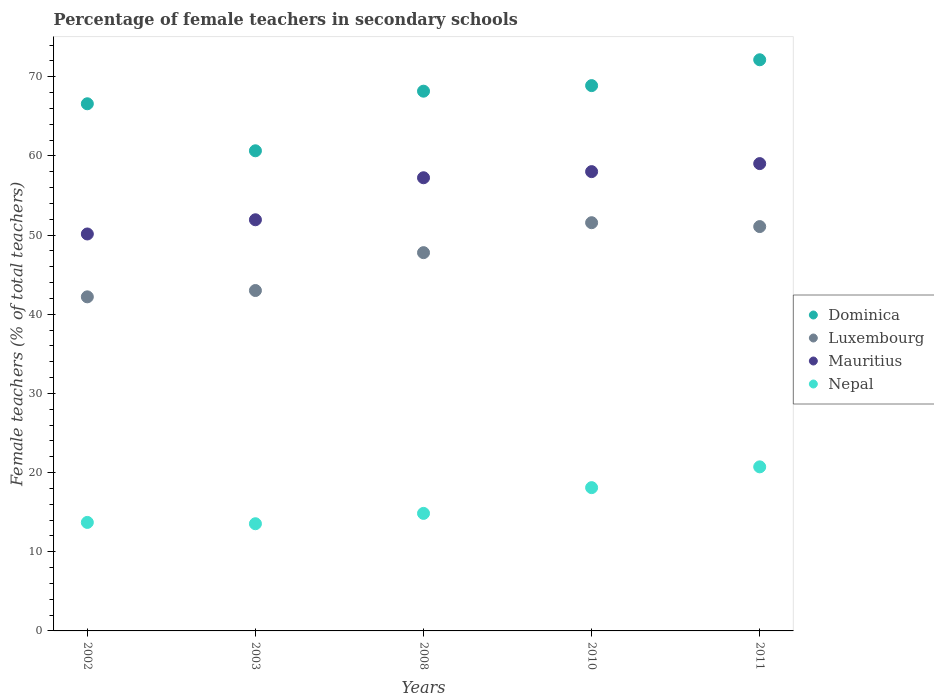How many different coloured dotlines are there?
Provide a short and direct response. 4. Is the number of dotlines equal to the number of legend labels?
Offer a terse response. Yes. What is the percentage of female teachers in Nepal in 2003?
Your answer should be very brief. 13.54. Across all years, what is the maximum percentage of female teachers in Dominica?
Your response must be concise. 72.15. Across all years, what is the minimum percentage of female teachers in Nepal?
Your answer should be very brief. 13.54. In which year was the percentage of female teachers in Luxembourg minimum?
Offer a terse response. 2002. What is the total percentage of female teachers in Luxembourg in the graph?
Offer a very short reply. 235.63. What is the difference between the percentage of female teachers in Nepal in 2003 and that in 2008?
Give a very brief answer. -1.31. What is the difference between the percentage of female teachers in Nepal in 2002 and the percentage of female teachers in Dominica in 2008?
Offer a very short reply. -54.48. What is the average percentage of female teachers in Mauritius per year?
Ensure brevity in your answer.  55.28. In the year 2010, what is the difference between the percentage of female teachers in Mauritius and percentage of female teachers in Dominica?
Provide a short and direct response. -10.86. In how many years, is the percentage of female teachers in Mauritius greater than 70 %?
Provide a succinct answer. 0. What is the ratio of the percentage of female teachers in Dominica in 2003 to that in 2011?
Give a very brief answer. 0.84. Is the percentage of female teachers in Nepal in 2002 less than that in 2010?
Offer a terse response. Yes. Is the difference between the percentage of female teachers in Mauritius in 2002 and 2010 greater than the difference between the percentage of female teachers in Dominica in 2002 and 2010?
Provide a succinct answer. No. What is the difference between the highest and the second highest percentage of female teachers in Mauritius?
Ensure brevity in your answer.  1.01. What is the difference between the highest and the lowest percentage of female teachers in Nepal?
Ensure brevity in your answer.  7.19. Is the sum of the percentage of female teachers in Dominica in 2003 and 2010 greater than the maximum percentage of female teachers in Nepal across all years?
Provide a short and direct response. Yes. Is the percentage of female teachers in Dominica strictly less than the percentage of female teachers in Mauritius over the years?
Provide a short and direct response. No. How many years are there in the graph?
Give a very brief answer. 5. Are the values on the major ticks of Y-axis written in scientific E-notation?
Make the answer very short. No. Does the graph contain any zero values?
Keep it short and to the point. No. How many legend labels are there?
Provide a short and direct response. 4. How are the legend labels stacked?
Provide a succinct answer. Vertical. What is the title of the graph?
Provide a succinct answer. Percentage of female teachers in secondary schools. Does "Small states" appear as one of the legend labels in the graph?
Provide a short and direct response. No. What is the label or title of the X-axis?
Make the answer very short. Years. What is the label or title of the Y-axis?
Offer a very short reply. Female teachers (% of total teachers). What is the Female teachers (% of total teachers) in Dominica in 2002?
Ensure brevity in your answer.  66.59. What is the Female teachers (% of total teachers) in Luxembourg in 2002?
Your answer should be very brief. 42.2. What is the Female teachers (% of total teachers) of Mauritius in 2002?
Ensure brevity in your answer.  50.14. What is the Female teachers (% of total teachers) in Nepal in 2002?
Your answer should be compact. 13.71. What is the Female teachers (% of total teachers) of Dominica in 2003?
Ensure brevity in your answer.  60.65. What is the Female teachers (% of total teachers) in Luxembourg in 2003?
Ensure brevity in your answer.  43. What is the Female teachers (% of total teachers) of Mauritius in 2003?
Your answer should be compact. 51.94. What is the Female teachers (% of total teachers) of Nepal in 2003?
Offer a terse response. 13.54. What is the Female teachers (% of total teachers) in Dominica in 2008?
Offer a very short reply. 68.18. What is the Female teachers (% of total teachers) of Luxembourg in 2008?
Your answer should be very brief. 47.78. What is the Female teachers (% of total teachers) of Mauritius in 2008?
Provide a short and direct response. 57.25. What is the Female teachers (% of total teachers) of Nepal in 2008?
Make the answer very short. 14.85. What is the Female teachers (% of total teachers) in Dominica in 2010?
Your answer should be compact. 68.88. What is the Female teachers (% of total teachers) of Luxembourg in 2010?
Make the answer very short. 51.57. What is the Female teachers (% of total teachers) of Mauritius in 2010?
Give a very brief answer. 58.02. What is the Female teachers (% of total teachers) of Nepal in 2010?
Make the answer very short. 18.1. What is the Female teachers (% of total teachers) in Dominica in 2011?
Keep it short and to the point. 72.15. What is the Female teachers (% of total teachers) of Luxembourg in 2011?
Your response must be concise. 51.08. What is the Female teachers (% of total teachers) of Mauritius in 2011?
Keep it short and to the point. 59.03. What is the Female teachers (% of total teachers) in Nepal in 2011?
Make the answer very short. 20.73. Across all years, what is the maximum Female teachers (% of total teachers) in Dominica?
Provide a short and direct response. 72.15. Across all years, what is the maximum Female teachers (% of total teachers) in Luxembourg?
Your response must be concise. 51.57. Across all years, what is the maximum Female teachers (% of total teachers) in Mauritius?
Make the answer very short. 59.03. Across all years, what is the maximum Female teachers (% of total teachers) in Nepal?
Offer a very short reply. 20.73. Across all years, what is the minimum Female teachers (% of total teachers) of Dominica?
Your answer should be very brief. 60.65. Across all years, what is the minimum Female teachers (% of total teachers) of Luxembourg?
Give a very brief answer. 42.2. Across all years, what is the minimum Female teachers (% of total teachers) of Mauritius?
Provide a succinct answer. 50.14. Across all years, what is the minimum Female teachers (% of total teachers) of Nepal?
Your response must be concise. 13.54. What is the total Female teachers (% of total teachers) of Dominica in the graph?
Keep it short and to the point. 336.46. What is the total Female teachers (% of total teachers) in Luxembourg in the graph?
Your answer should be compact. 235.63. What is the total Female teachers (% of total teachers) in Mauritius in the graph?
Ensure brevity in your answer.  276.38. What is the total Female teachers (% of total teachers) in Nepal in the graph?
Your answer should be compact. 80.92. What is the difference between the Female teachers (% of total teachers) of Dominica in 2002 and that in 2003?
Your answer should be compact. 5.94. What is the difference between the Female teachers (% of total teachers) of Luxembourg in 2002 and that in 2003?
Ensure brevity in your answer.  -0.8. What is the difference between the Female teachers (% of total teachers) of Mauritius in 2002 and that in 2003?
Give a very brief answer. -1.8. What is the difference between the Female teachers (% of total teachers) in Nepal in 2002 and that in 2003?
Give a very brief answer. 0.17. What is the difference between the Female teachers (% of total teachers) of Dominica in 2002 and that in 2008?
Make the answer very short. -1.59. What is the difference between the Female teachers (% of total teachers) in Luxembourg in 2002 and that in 2008?
Ensure brevity in your answer.  -5.58. What is the difference between the Female teachers (% of total teachers) in Mauritius in 2002 and that in 2008?
Make the answer very short. -7.1. What is the difference between the Female teachers (% of total teachers) of Nepal in 2002 and that in 2008?
Offer a terse response. -1.14. What is the difference between the Female teachers (% of total teachers) in Dominica in 2002 and that in 2010?
Make the answer very short. -2.29. What is the difference between the Female teachers (% of total teachers) in Luxembourg in 2002 and that in 2010?
Provide a succinct answer. -9.37. What is the difference between the Female teachers (% of total teachers) of Mauritius in 2002 and that in 2010?
Offer a terse response. -7.88. What is the difference between the Female teachers (% of total teachers) of Nepal in 2002 and that in 2010?
Ensure brevity in your answer.  -4.39. What is the difference between the Female teachers (% of total teachers) of Dominica in 2002 and that in 2011?
Provide a short and direct response. -5.56. What is the difference between the Female teachers (% of total teachers) of Luxembourg in 2002 and that in 2011?
Offer a terse response. -8.88. What is the difference between the Female teachers (% of total teachers) of Mauritius in 2002 and that in 2011?
Provide a succinct answer. -8.89. What is the difference between the Female teachers (% of total teachers) in Nepal in 2002 and that in 2011?
Provide a succinct answer. -7.02. What is the difference between the Female teachers (% of total teachers) in Dominica in 2003 and that in 2008?
Make the answer very short. -7.53. What is the difference between the Female teachers (% of total teachers) of Luxembourg in 2003 and that in 2008?
Make the answer very short. -4.78. What is the difference between the Female teachers (% of total teachers) in Mauritius in 2003 and that in 2008?
Offer a very short reply. -5.31. What is the difference between the Female teachers (% of total teachers) in Nepal in 2003 and that in 2008?
Give a very brief answer. -1.31. What is the difference between the Female teachers (% of total teachers) in Dominica in 2003 and that in 2010?
Offer a terse response. -8.23. What is the difference between the Female teachers (% of total teachers) of Luxembourg in 2003 and that in 2010?
Your answer should be very brief. -8.57. What is the difference between the Female teachers (% of total teachers) in Mauritius in 2003 and that in 2010?
Offer a terse response. -6.08. What is the difference between the Female teachers (% of total teachers) in Nepal in 2003 and that in 2010?
Make the answer very short. -4.56. What is the difference between the Female teachers (% of total teachers) of Dominica in 2003 and that in 2011?
Make the answer very short. -11.5. What is the difference between the Female teachers (% of total teachers) of Luxembourg in 2003 and that in 2011?
Keep it short and to the point. -8.08. What is the difference between the Female teachers (% of total teachers) of Mauritius in 2003 and that in 2011?
Your answer should be compact. -7.1. What is the difference between the Female teachers (% of total teachers) of Nepal in 2003 and that in 2011?
Keep it short and to the point. -7.19. What is the difference between the Female teachers (% of total teachers) in Dominica in 2008 and that in 2010?
Ensure brevity in your answer.  -0.7. What is the difference between the Female teachers (% of total teachers) in Luxembourg in 2008 and that in 2010?
Your response must be concise. -3.78. What is the difference between the Female teachers (% of total teachers) in Mauritius in 2008 and that in 2010?
Provide a succinct answer. -0.77. What is the difference between the Female teachers (% of total teachers) in Nepal in 2008 and that in 2010?
Provide a succinct answer. -3.25. What is the difference between the Female teachers (% of total teachers) in Dominica in 2008 and that in 2011?
Keep it short and to the point. -3.97. What is the difference between the Female teachers (% of total teachers) of Luxembourg in 2008 and that in 2011?
Give a very brief answer. -3.29. What is the difference between the Female teachers (% of total teachers) of Mauritius in 2008 and that in 2011?
Your answer should be very brief. -1.79. What is the difference between the Female teachers (% of total teachers) of Nepal in 2008 and that in 2011?
Provide a short and direct response. -5.88. What is the difference between the Female teachers (% of total teachers) of Dominica in 2010 and that in 2011?
Your answer should be compact. -3.27. What is the difference between the Female teachers (% of total teachers) in Luxembourg in 2010 and that in 2011?
Your answer should be compact. 0.49. What is the difference between the Female teachers (% of total teachers) of Mauritius in 2010 and that in 2011?
Give a very brief answer. -1.01. What is the difference between the Female teachers (% of total teachers) of Nepal in 2010 and that in 2011?
Your response must be concise. -2.63. What is the difference between the Female teachers (% of total teachers) of Dominica in 2002 and the Female teachers (% of total teachers) of Luxembourg in 2003?
Keep it short and to the point. 23.59. What is the difference between the Female teachers (% of total teachers) in Dominica in 2002 and the Female teachers (% of total teachers) in Mauritius in 2003?
Make the answer very short. 14.65. What is the difference between the Female teachers (% of total teachers) of Dominica in 2002 and the Female teachers (% of total teachers) of Nepal in 2003?
Your response must be concise. 53.05. What is the difference between the Female teachers (% of total teachers) in Luxembourg in 2002 and the Female teachers (% of total teachers) in Mauritius in 2003?
Ensure brevity in your answer.  -9.74. What is the difference between the Female teachers (% of total teachers) in Luxembourg in 2002 and the Female teachers (% of total teachers) in Nepal in 2003?
Your answer should be very brief. 28.66. What is the difference between the Female teachers (% of total teachers) of Mauritius in 2002 and the Female teachers (% of total teachers) of Nepal in 2003?
Offer a very short reply. 36.6. What is the difference between the Female teachers (% of total teachers) of Dominica in 2002 and the Female teachers (% of total teachers) of Luxembourg in 2008?
Give a very brief answer. 18.81. What is the difference between the Female teachers (% of total teachers) of Dominica in 2002 and the Female teachers (% of total teachers) of Mauritius in 2008?
Offer a very short reply. 9.35. What is the difference between the Female teachers (% of total teachers) in Dominica in 2002 and the Female teachers (% of total teachers) in Nepal in 2008?
Keep it short and to the point. 51.74. What is the difference between the Female teachers (% of total teachers) in Luxembourg in 2002 and the Female teachers (% of total teachers) in Mauritius in 2008?
Provide a succinct answer. -15.04. What is the difference between the Female teachers (% of total teachers) in Luxembourg in 2002 and the Female teachers (% of total teachers) in Nepal in 2008?
Keep it short and to the point. 27.36. What is the difference between the Female teachers (% of total teachers) in Mauritius in 2002 and the Female teachers (% of total teachers) in Nepal in 2008?
Keep it short and to the point. 35.3. What is the difference between the Female teachers (% of total teachers) in Dominica in 2002 and the Female teachers (% of total teachers) in Luxembourg in 2010?
Your answer should be very brief. 15.02. What is the difference between the Female teachers (% of total teachers) of Dominica in 2002 and the Female teachers (% of total teachers) of Mauritius in 2010?
Make the answer very short. 8.57. What is the difference between the Female teachers (% of total teachers) of Dominica in 2002 and the Female teachers (% of total teachers) of Nepal in 2010?
Ensure brevity in your answer.  48.49. What is the difference between the Female teachers (% of total teachers) of Luxembourg in 2002 and the Female teachers (% of total teachers) of Mauritius in 2010?
Provide a short and direct response. -15.82. What is the difference between the Female teachers (% of total teachers) in Luxembourg in 2002 and the Female teachers (% of total teachers) in Nepal in 2010?
Keep it short and to the point. 24.1. What is the difference between the Female teachers (% of total teachers) in Mauritius in 2002 and the Female teachers (% of total teachers) in Nepal in 2010?
Your answer should be compact. 32.04. What is the difference between the Female teachers (% of total teachers) of Dominica in 2002 and the Female teachers (% of total teachers) of Luxembourg in 2011?
Keep it short and to the point. 15.51. What is the difference between the Female teachers (% of total teachers) of Dominica in 2002 and the Female teachers (% of total teachers) of Mauritius in 2011?
Ensure brevity in your answer.  7.56. What is the difference between the Female teachers (% of total teachers) of Dominica in 2002 and the Female teachers (% of total teachers) of Nepal in 2011?
Your answer should be very brief. 45.87. What is the difference between the Female teachers (% of total teachers) of Luxembourg in 2002 and the Female teachers (% of total teachers) of Mauritius in 2011?
Your response must be concise. -16.83. What is the difference between the Female teachers (% of total teachers) of Luxembourg in 2002 and the Female teachers (% of total teachers) of Nepal in 2011?
Provide a short and direct response. 21.48. What is the difference between the Female teachers (% of total teachers) of Mauritius in 2002 and the Female teachers (% of total teachers) of Nepal in 2011?
Keep it short and to the point. 29.42. What is the difference between the Female teachers (% of total teachers) in Dominica in 2003 and the Female teachers (% of total teachers) in Luxembourg in 2008?
Make the answer very short. 12.87. What is the difference between the Female teachers (% of total teachers) in Dominica in 2003 and the Female teachers (% of total teachers) in Mauritius in 2008?
Provide a succinct answer. 3.41. What is the difference between the Female teachers (% of total teachers) of Dominica in 2003 and the Female teachers (% of total teachers) of Nepal in 2008?
Give a very brief answer. 45.81. What is the difference between the Female teachers (% of total teachers) in Luxembourg in 2003 and the Female teachers (% of total teachers) in Mauritius in 2008?
Offer a very short reply. -14.24. What is the difference between the Female teachers (% of total teachers) of Luxembourg in 2003 and the Female teachers (% of total teachers) of Nepal in 2008?
Offer a very short reply. 28.15. What is the difference between the Female teachers (% of total teachers) of Mauritius in 2003 and the Female teachers (% of total teachers) of Nepal in 2008?
Keep it short and to the point. 37.09. What is the difference between the Female teachers (% of total teachers) in Dominica in 2003 and the Female teachers (% of total teachers) in Luxembourg in 2010?
Provide a succinct answer. 9.08. What is the difference between the Female teachers (% of total teachers) of Dominica in 2003 and the Female teachers (% of total teachers) of Mauritius in 2010?
Provide a succinct answer. 2.63. What is the difference between the Female teachers (% of total teachers) in Dominica in 2003 and the Female teachers (% of total teachers) in Nepal in 2010?
Provide a short and direct response. 42.55. What is the difference between the Female teachers (% of total teachers) of Luxembourg in 2003 and the Female teachers (% of total teachers) of Mauritius in 2010?
Provide a short and direct response. -15.02. What is the difference between the Female teachers (% of total teachers) of Luxembourg in 2003 and the Female teachers (% of total teachers) of Nepal in 2010?
Provide a succinct answer. 24.9. What is the difference between the Female teachers (% of total teachers) of Mauritius in 2003 and the Female teachers (% of total teachers) of Nepal in 2010?
Your response must be concise. 33.84. What is the difference between the Female teachers (% of total teachers) in Dominica in 2003 and the Female teachers (% of total teachers) in Luxembourg in 2011?
Give a very brief answer. 9.57. What is the difference between the Female teachers (% of total teachers) in Dominica in 2003 and the Female teachers (% of total teachers) in Mauritius in 2011?
Make the answer very short. 1.62. What is the difference between the Female teachers (% of total teachers) in Dominica in 2003 and the Female teachers (% of total teachers) in Nepal in 2011?
Provide a succinct answer. 39.93. What is the difference between the Female teachers (% of total teachers) in Luxembourg in 2003 and the Female teachers (% of total teachers) in Mauritius in 2011?
Offer a very short reply. -16.03. What is the difference between the Female teachers (% of total teachers) in Luxembourg in 2003 and the Female teachers (% of total teachers) in Nepal in 2011?
Ensure brevity in your answer.  22.28. What is the difference between the Female teachers (% of total teachers) of Mauritius in 2003 and the Female teachers (% of total teachers) of Nepal in 2011?
Provide a short and direct response. 31.21. What is the difference between the Female teachers (% of total teachers) in Dominica in 2008 and the Female teachers (% of total teachers) in Luxembourg in 2010?
Offer a terse response. 16.61. What is the difference between the Female teachers (% of total teachers) in Dominica in 2008 and the Female teachers (% of total teachers) in Mauritius in 2010?
Provide a short and direct response. 10.16. What is the difference between the Female teachers (% of total teachers) in Dominica in 2008 and the Female teachers (% of total teachers) in Nepal in 2010?
Your response must be concise. 50.08. What is the difference between the Female teachers (% of total teachers) of Luxembourg in 2008 and the Female teachers (% of total teachers) of Mauritius in 2010?
Offer a terse response. -10.24. What is the difference between the Female teachers (% of total teachers) of Luxembourg in 2008 and the Female teachers (% of total teachers) of Nepal in 2010?
Offer a very short reply. 29.68. What is the difference between the Female teachers (% of total teachers) in Mauritius in 2008 and the Female teachers (% of total teachers) in Nepal in 2010?
Offer a very short reply. 39.15. What is the difference between the Female teachers (% of total teachers) of Dominica in 2008 and the Female teachers (% of total teachers) of Luxembourg in 2011?
Offer a very short reply. 17.1. What is the difference between the Female teachers (% of total teachers) in Dominica in 2008 and the Female teachers (% of total teachers) in Mauritius in 2011?
Ensure brevity in your answer.  9.15. What is the difference between the Female teachers (% of total teachers) in Dominica in 2008 and the Female teachers (% of total teachers) in Nepal in 2011?
Make the answer very short. 47.46. What is the difference between the Female teachers (% of total teachers) of Luxembourg in 2008 and the Female teachers (% of total teachers) of Mauritius in 2011?
Ensure brevity in your answer.  -11.25. What is the difference between the Female teachers (% of total teachers) in Luxembourg in 2008 and the Female teachers (% of total teachers) in Nepal in 2011?
Your response must be concise. 27.06. What is the difference between the Female teachers (% of total teachers) in Mauritius in 2008 and the Female teachers (% of total teachers) in Nepal in 2011?
Give a very brief answer. 36.52. What is the difference between the Female teachers (% of total teachers) of Dominica in 2010 and the Female teachers (% of total teachers) of Luxembourg in 2011?
Offer a very short reply. 17.81. What is the difference between the Female teachers (% of total teachers) in Dominica in 2010 and the Female teachers (% of total teachers) in Mauritius in 2011?
Provide a succinct answer. 9.85. What is the difference between the Female teachers (% of total teachers) of Dominica in 2010 and the Female teachers (% of total teachers) of Nepal in 2011?
Your response must be concise. 48.16. What is the difference between the Female teachers (% of total teachers) in Luxembourg in 2010 and the Female teachers (% of total teachers) in Mauritius in 2011?
Your answer should be compact. -7.47. What is the difference between the Female teachers (% of total teachers) in Luxembourg in 2010 and the Female teachers (% of total teachers) in Nepal in 2011?
Offer a very short reply. 30.84. What is the difference between the Female teachers (% of total teachers) of Mauritius in 2010 and the Female teachers (% of total teachers) of Nepal in 2011?
Your response must be concise. 37.29. What is the average Female teachers (% of total teachers) of Dominica per year?
Ensure brevity in your answer.  67.29. What is the average Female teachers (% of total teachers) of Luxembourg per year?
Make the answer very short. 47.13. What is the average Female teachers (% of total teachers) of Mauritius per year?
Your answer should be compact. 55.28. What is the average Female teachers (% of total teachers) of Nepal per year?
Your answer should be compact. 16.18. In the year 2002, what is the difference between the Female teachers (% of total teachers) in Dominica and Female teachers (% of total teachers) in Luxembourg?
Your answer should be very brief. 24.39. In the year 2002, what is the difference between the Female teachers (% of total teachers) of Dominica and Female teachers (% of total teachers) of Mauritius?
Ensure brevity in your answer.  16.45. In the year 2002, what is the difference between the Female teachers (% of total teachers) of Dominica and Female teachers (% of total teachers) of Nepal?
Make the answer very short. 52.88. In the year 2002, what is the difference between the Female teachers (% of total teachers) in Luxembourg and Female teachers (% of total teachers) in Mauritius?
Keep it short and to the point. -7.94. In the year 2002, what is the difference between the Female teachers (% of total teachers) in Luxembourg and Female teachers (% of total teachers) in Nepal?
Your answer should be compact. 28.5. In the year 2002, what is the difference between the Female teachers (% of total teachers) in Mauritius and Female teachers (% of total teachers) in Nepal?
Provide a succinct answer. 36.44. In the year 2003, what is the difference between the Female teachers (% of total teachers) in Dominica and Female teachers (% of total teachers) in Luxembourg?
Offer a terse response. 17.65. In the year 2003, what is the difference between the Female teachers (% of total teachers) in Dominica and Female teachers (% of total teachers) in Mauritius?
Your answer should be very brief. 8.71. In the year 2003, what is the difference between the Female teachers (% of total teachers) of Dominica and Female teachers (% of total teachers) of Nepal?
Offer a very short reply. 47.11. In the year 2003, what is the difference between the Female teachers (% of total teachers) of Luxembourg and Female teachers (% of total teachers) of Mauritius?
Make the answer very short. -8.94. In the year 2003, what is the difference between the Female teachers (% of total teachers) of Luxembourg and Female teachers (% of total teachers) of Nepal?
Offer a terse response. 29.46. In the year 2003, what is the difference between the Female teachers (% of total teachers) of Mauritius and Female teachers (% of total teachers) of Nepal?
Provide a short and direct response. 38.4. In the year 2008, what is the difference between the Female teachers (% of total teachers) in Dominica and Female teachers (% of total teachers) in Luxembourg?
Ensure brevity in your answer.  20.4. In the year 2008, what is the difference between the Female teachers (% of total teachers) of Dominica and Female teachers (% of total teachers) of Mauritius?
Offer a terse response. 10.94. In the year 2008, what is the difference between the Female teachers (% of total teachers) of Dominica and Female teachers (% of total teachers) of Nepal?
Give a very brief answer. 53.33. In the year 2008, what is the difference between the Female teachers (% of total teachers) in Luxembourg and Female teachers (% of total teachers) in Mauritius?
Ensure brevity in your answer.  -9.46. In the year 2008, what is the difference between the Female teachers (% of total teachers) in Luxembourg and Female teachers (% of total teachers) in Nepal?
Your response must be concise. 32.94. In the year 2008, what is the difference between the Female teachers (% of total teachers) in Mauritius and Female teachers (% of total teachers) in Nepal?
Make the answer very short. 42.4. In the year 2010, what is the difference between the Female teachers (% of total teachers) of Dominica and Female teachers (% of total teachers) of Luxembourg?
Provide a succinct answer. 17.32. In the year 2010, what is the difference between the Female teachers (% of total teachers) of Dominica and Female teachers (% of total teachers) of Mauritius?
Make the answer very short. 10.86. In the year 2010, what is the difference between the Female teachers (% of total teachers) of Dominica and Female teachers (% of total teachers) of Nepal?
Your response must be concise. 50.78. In the year 2010, what is the difference between the Female teachers (% of total teachers) in Luxembourg and Female teachers (% of total teachers) in Mauritius?
Give a very brief answer. -6.45. In the year 2010, what is the difference between the Female teachers (% of total teachers) of Luxembourg and Female teachers (% of total teachers) of Nepal?
Provide a succinct answer. 33.47. In the year 2010, what is the difference between the Female teachers (% of total teachers) in Mauritius and Female teachers (% of total teachers) in Nepal?
Make the answer very short. 39.92. In the year 2011, what is the difference between the Female teachers (% of total teachers) of Dominica and Female teachers (% of total teachers) of Luxembourg?
Your response must be concise. 21.07. In the year 2011, what is the difference between the Female teachers (% of total teachers) of Dominica and Female teachers (% of total teachers) of Mauritius?
Offer a very short reply. 13.12. In the year 2011, what is the difference between the Female teachers (% of total teachers) of Dominica and Female teachers (% of total teachers) of Nepal?
Offer a very short reply. 51.42. In the year 2011, what is the difference between the Female teachers (% of total teachers) of Luxembourg and Female teachers (% of total teachers) of Mauritius?
Give a very brief answer. -7.96. In the year 2011, what is the difference between the Female teachers (% of total teachers) in Luxembourg and Female teachers (% of total teachers) in Nepal?
Your answer should be compact. 30.35. In the year 2011, what is the difference between the Female teachers (% of total teachers) in Mauritius and Female teachers (% of total teachers) in Nepal?
Your response must be concise. 38.31. What is the ratio of the Female teachers (% of total teachers) in Dominica in 2002 to that in 2003?
Your answer should be very brief. 1.1. What is the ratio of the Female teachers (% of total teachers) of Luxembourg in 2002 to that in 2003?
Offer a terse response. 0.98. What is the ratio of the Female teachers (% of total teachers) of Mauritius in 2002 to that in 2003?
Ensure brevity in your answer.  0.97. What is the ratio of the Female teachers (% of total teachers) in Nepal in 2002 to that in 2003?
Provide a short and direct response. 1.01. What is the ratio of the Female teachers (% of total teachers) of Dominica in 2002 to that in 2008?
Keep it short and to the point. 0.98. What is the ratio of the Female teachers (% of total teachers) of Luxembourg in 2002 to that in 2008?
Your answer should be very brief. 0.88. What is the ratio of the Female teachers (% of total teachers) of Mauritius in 2002 to that in 2008?
Your response must be concise. 0.88. What is the ratio of the Female teachers (% of total teachers) in Nepal in 2002 to that in 2008?
Your answer should be very brief. 0.92. What is the ratio of the Female teachers (% of total teachers) of Dominica in 2002 to that in 2010?
Ensure brevity in your answer.  0.97. What is the ratio of the Female teachers (% of total teachers) in Luxembourg in 2002 to that in 2010?
Your response must be concise. 0.82. What is the ratio of the Female teachers (% of total teachers) of Mauritius in 2002 to that in 2010?
Give a very brief answer. 0.86. What is the ratio of the Female teachers (% of total teachers) in Nepal in 2002 to that in 2010?
Give a very brief answer. 0.76. What is the ratio of the Female teachers (% of total teachers) in Dominica in 2002 to that in 2011?
Give a very brief answer. 0.92. What is the ratio of the Female teachers (% of total teachers) in Luxembourg in 2002 to that in 2011?
Your answer should be compact. 0.83. What is the ratio of the Female teachers (% of total teachers) in Mauritius in 2002 to that in 2011?
Offer a terse response. 0.85. What is the ratio of the Female teachers (% of total teachers) of Nepal in 2002 to that in 2011?
Keep it short and to the point. 0.66. What is the ratio of the Female teachers (% of total teachers) in Dominica in 2003 to that in 2008?
Give a very brief answer. 0.89. What is the ratio of the Female teachers (% of total teachers) in Luxembourg in 2003 to that in 2008?
Offer a terse response. 0.9. What is the ratio of the Female teachers (% of total teachers) in Mauritius in 2003 to that in 2008?
Provide a short and direct response. 0.91. What is the ratio of the Female teachers (% of total teachers) of Nepal in 2003 to that in 2008?
Offer a terse response. 0.91. What is the ratio of the Female teachers (% of total teachers) of Dominica in 2003 to that in 2010?
Provide a succinct answer. 0.88. What is the ratio of the Female teachers (% of total teachers) of Luxembourg in 2003 to that in 2010?
Keep it short and to the point. 0.83. What is the ratio of the Female teachers (% of total teachers) of Mauritius in 2003 to that in 2010?
Offer a very short reply. 0.9. What is the ratio of the Female teachers (% of total teachers) in Nepal in 2003 to that in 2010?
Your response must be concise. 0.75. What is the ratio of the Female teachers (% of total teachers) of Dominica in 2003 to that in 2011?
Give a very brief answer. 0.84. What is the ratio of the Female teachers (% of total teachers) in Luxembourg in 2003 to that in 2011?
Your response must be concise. 0.84. What is the ratio of the Female teachers (% of total teachers) of Mauritius in 2003 to that in 2011?
Your answer should be very brief. 0.88. What is the ratio of the Female teachers (% of total teachers) of Nepal in 2003 to that in 2011?
Offer a terse response. 0.65. What is the ratio of the Female teachers (% of total teachers) in Luxembourg in 2008 to that in 2010?
Your answer should be compact. 0.93. What is the ratio of the Female teachers (% of total teachers) of Mauritius in 2008 to that in 2010?
Provide a short and direct response. 0.99. What is the ratio of the Female teachers (% of total teachers) of Nepal in 2008 to that in 2010?
Your answer should be compact. 0.82. What is the ratio of the Female teachers (% of total teachers) of Dominica in 2008 to that in 2011?
Ensure brevity in your answer.  0.94. What is the ratio of the Female teachers (% of total teachers) of Luxembourg in 2008 to that in 2011?
Provide a short and direct response. 0.94. What is the ratio of the Female teachers (% of total teachers) of Mauritius in 2008 to that in 2011?
Provide a succinct answer. 0.97. What is the ratio of the Female teachers (% of total teachers) of Nepal in 2008 to that in 2011?
Provide a succinct answer. 0.72. What is the ratio of the Female teachers (% of total teachers) in Dominica in 2010 to that in 2011?
Offer a very short reply. 0.95. What is the ratio of the Female teachers (% of total teachers) in Luxembourg in 2010 to that in 2011?
Ensure brevity in your answer.  1.01. What is the ratio of the Female teachers (% of total teachers) of Mauritius in 2010 to that in 2011?
Your answer should be compact. 0.98. What is the ratio of the Female teachers (% of total teachers) in Nepal in 2010 to that in 2011?
Provide a short and direct response. 0.87. What is the difference between the highest and the second highest Female teachers (% of total teachers) of Dominica?
Keep it short and to the point. 3.27. What is the difference between the highest and the second highest Female teachers (% of total teachers) of Luxembourg?
Provide a succinct answer. 0.49. What is the difference between the highest and the second highest Female teachers (% of total teachers) of Mauritius?
Give a very brief answer. 1.01. What is the difference between the highest and the second highest Female teachers (% of total teachers) of Nepal?
Your answer should be compact. 2.63. What is the difference between the highest and the lowest Female teachers (% of total teachers) of Dominica?
Offer a very short reply. 11.5. What is the difference between the highest and the lowest Female teachers (% of total teachers) of Luxembourg?
Ensure brevity in your answer.  9.37. What is the difference between the highest and the lowest Female teachers (% of total teachers) of Mauritius?
Provide a short and direct response. 8.89. What is the difference between the highest and the lowest Female teachers (% of total teachers) of Nepal?
Your answer should be compact. 7.19. 